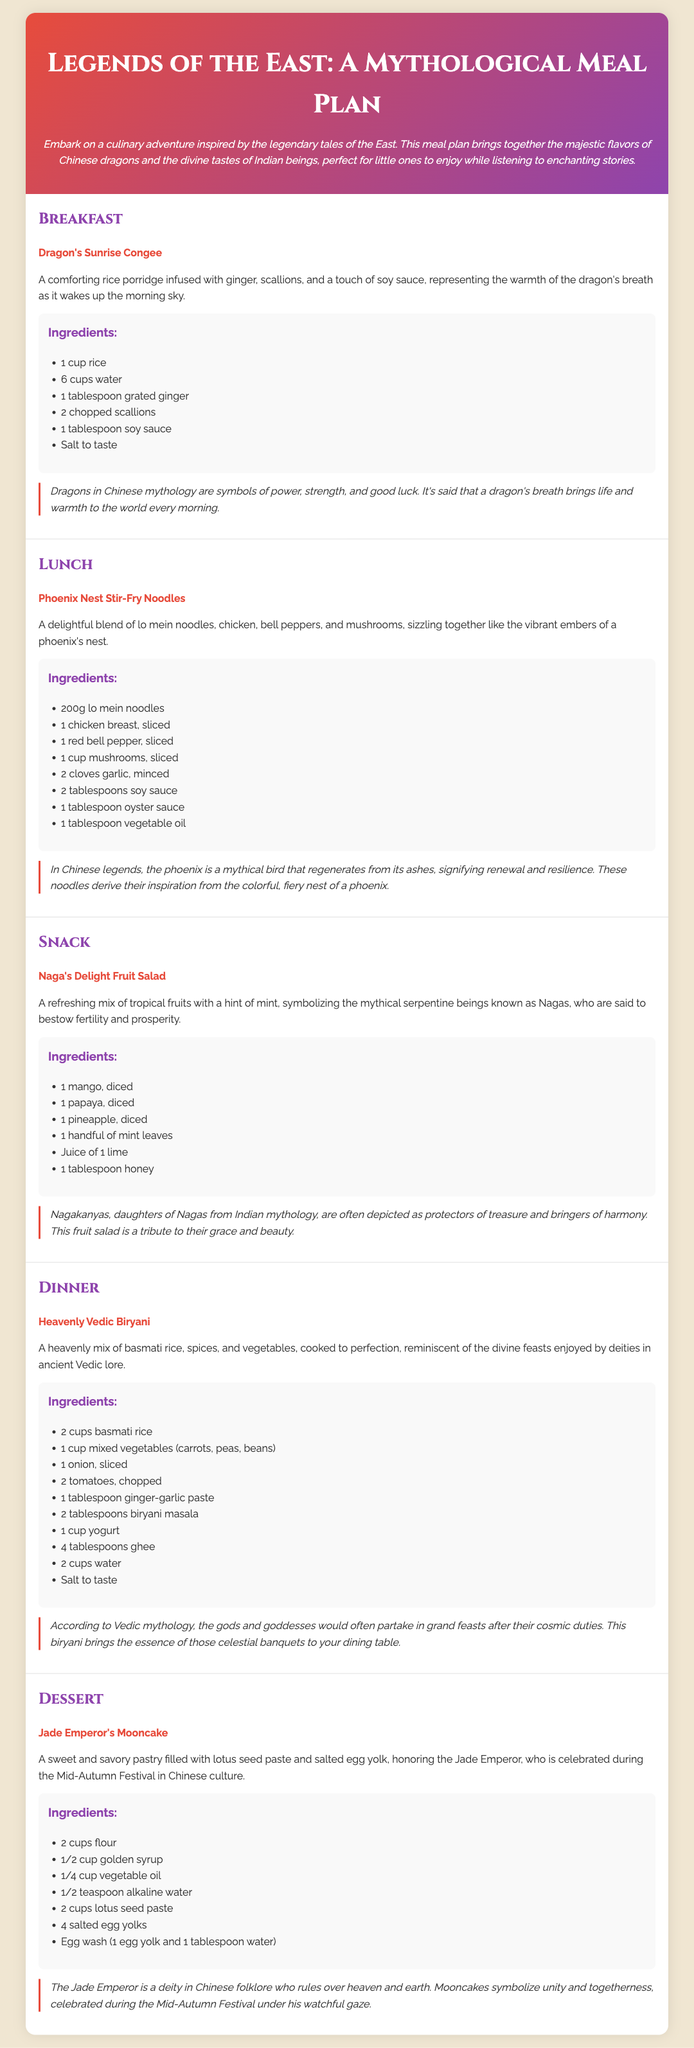What is the dish for breakfast? The breakfast dish is listed under the Breakfast section, which is "Dragon's Sunrise Congee."
Answer: Dragon's Sunrise Congee How many ingredients are in the Phoenix Nest Stir-Fry Noodles? The ingredients section lists 8 items needed for the dish "Phoenix Nest Stir-Fry Noodles."
Answer: 8 What is the main ingredient used in the Jade Emperor's Mooncake? The main filling for the mooncake is specified as "lotus seed paste."
Answer: lotus seed paste What creatures does the Naga's Delight Fruit Salad symbolize? The fruit salad represents "Nagas," mythical serpentine beings from Indian mythology.
Answer: Nagas What type of cuisine is represented in the Heavenly Vedic Biryani? The dish "Heavenly Vedic Biryani" is associated with "Vedic" cuisine from Indian mythology.
Answer: Vedic Which festival is celebrated with the Jade Emperor's Mooncake? The mooncake is celebrated during the "Mid-Autumn Festival."
Answer: Mid-Autumn Festival What is the main vegetable included in the Dragon's Sunrise Congee? The main vegetable mentioned is "scallions."
Answer: scallions What mythical creature regenerates from its ashes? The mythical creature that regenerates from its ashes is the "phoenix."
Answer: phoenix 